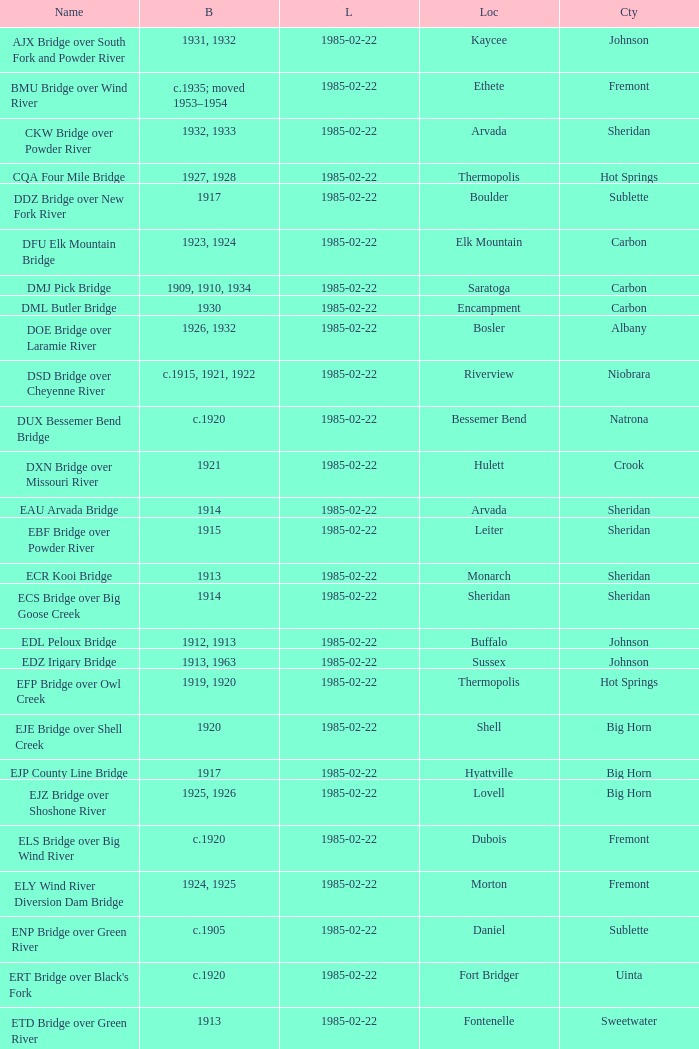What is the listed for the bridge at Daniel in Sublette county? 1985-02-22. 